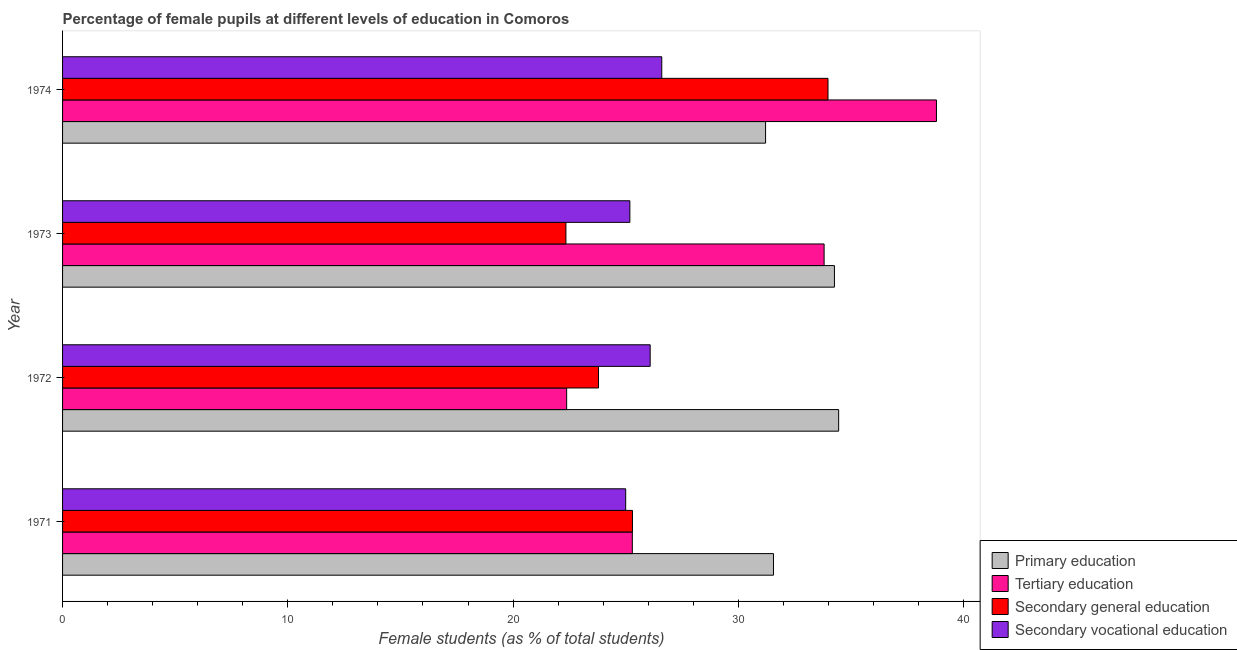How many different coloured bars are there?
Ensure brevity in your answer.  4. How many groups of bars are there?
Ensure brevity in your answer.  4. Are the number of bars per tick equal to the number of legend labels?
Offer a very short reply. Yes. How many bars are there on the 3rd tick from the top?
Keep it short and to the point. 4. What is the label of the 4th group of bars from the top?
Provide a short and direct response. 1971. In how many cases, is the number of bars for a given year not equal to the number of legend labels?
Your response must be concise. 0. What is the percentage of female students in tertiary education in 1973?
Provide a short and direct response. 33.81. Across all years, what is the maximum percentage of female students in secondary education?
Offer a very short reply. 33.98. Across all years, what is the minimum percentage of female students in secondary education?
Make the answer very short. 22.35. In which year was the percentage of female students in secondary vocational education maximum?
Offer a terse response. 1974. In which year was the percentage of female students in primary education minimum?
Your answer should be compact. 1974. What is the total percentage of female students in secondary vocational education in the graph?
Offer a very short reply. 102.87. What is the difference between the percentage of female students in secondary education in 1972 and that in 1973?
Make the answer very short. 1.45. What is the difference between the percentage of female students in secondary education in 1972 and the percentage of female students in tertiary education in 1974?
Provide a short and direct response. -15. What is the average percentage of female students in secondary education per year?
Make the answer very short. 26.36. In the year 1973, what is the difference between the percentage of female students in secondary vocational education and percentage of female students in primary education?
Offer a terse response. -9.08. What is the ratio of the percentage of female students in tertiary education in 1971 to that in 1974?
Offer a very short reply. 0.65. What is the difference between the highest and the second highest percentage of female students in primary education?
Provide a succinct answer. 0.19. What is the difference between the highest and the lowest percentage of female students in secondary education?
Give a very brief answer. 11.64. What does the 2nd bar from the top in 1973 represents?
Offer a terse response. Secondary general education. What does the 2nd bar from the bottom in 1974 represents?
Provide a succinct answer. Tertiary education. How many years are there in the graph?
Give a very brief answer. 4. What is the difference between two consecutive major ticks on the X-axis?
Make the answer very short. 10. Does the graph contain grids?
Your answer should be very brief. No. Where does the legend appear in the graph?
Your response must be concise. Bottom right. How many legend labels are there?
Your response must be concise. 4. How are the legend labels stacked?
Your answer should be compact. Vertical. What is the title of the graph?
Keep it short and to the point. Percentage of female pupils at different levels of education in Comoros. Does "Salary of employees" appear as one of the legend labels in the graph?
Your answer should be very brief. No. What is the label or title of the X-axis?
Give a very brief answer. Female students (as % of total students). What is the Female students (as % of total students) in Primary education in 1971?
Make the answer very short. 31.56. What is the Female students (as % of total students) in Tertiary education in 1971?
Your answer should be very brief. 25.29. What is the Female students (as % of total students) of Secondary general education in 1971?
Provide a succinct answer. 25.3. What is the Female students (as % of total students) of Primary education in 1972?
Provide a short and direct response. 34.45. What is the Female students (as % of total students) in Tertiary education in 1972?
Your response must be concise. 22.38. What is the Female students (as % of total students) in Secondary general education in 1972?
Provide a short and direct response. 23.79. What is the Female students (as % of total students) of Secondary vocational education in 1972?
Offer a very short reply. 26.09. What is the Female students (as % of total students) of Primary education in 1973?
Your response must be concise. 34.27. What is the Female students (as % of total students) in Tertiary education in 1973?
Make the answer very short. 33.81. What is the Female students (as % of total students) in Secondary general education in 1973?
Your response must be concise. 22.35. What is the Female students (as % of total students) in Secondary vocational education in 1973?
Offer a terse response. 25.19. What is the Female students (as % of total students) in Primary education in 1974?
Your response must be concise. 31.21. What is the Female students (as % of total students) in Tertiary education in 1974?
Offer a terse response. 38.8. What is the Female students (as % of total students) of Secondary general education in 1974?
Keep it short and to the point. 33.98. What is the Female students (as % of total students) of Secondary vocational education in 1974?
Offer a very short reply. 26.6. Across all years, what is the maximum Female students (as % of total students) of Primary education?
Make the answer very short. 34.45. Across all years, what is the maximum Female students (as % of total students) of Tertiary education?
Give a very brief answer. 38.8. Across all years, what is the maximum Female students (as % of total students) in Secondary general education?
Your answer should be compact. 33.98. Across all years, what is the maximum Female students (as % of total students) of Secondary vocational education?
Provide a succinct answer. 26.6. Across all years, what is the minimum Female students (as % of total students) of Primary education?
Offer a terse response. 31.21. Across all years, what is the minimum Female students (as % of total students) in Tertiary education?
Ensure brevity in your answer.  22.38. Across all years, what is the minimum Female students (as % of total students) in Secondary general education?
Provide a succinct answer. 22.35. What is the total Female students (as % of total students) of Primary education in the graph?
Provide a short and direct response. 131.49. What is the total Female students (as % of total students) of Tertiary education in the graph?
Ensure brevity in your answer.  120.28. What is the total Female students (as % of total students) of Secondary general education in the graph?
Provide a succinct answer. 105.42. What is the total Female students (as % of total students) of Secondary vocational education in the graph?
Your answer should be very brief. 102.87. What is the difference between the Female students (as % of total students) of Primary education in 1971 and that in 1972?
Your response must be concise. -2.89. What is the difference between the Female students (as % of total students) in Tertiary education in 1971 and that in 1972?
Your response must be concise. 2.92. What is the difference between the Female students (as % of total students) of Secondary general education in 1971 and that in 1972?
Ensure brevity in your answer.  1.51. What is the difference between the Female students (as % of total students) in Secondary vocational education in 1971 and that in 1972?
Make the answer very short. -1.09. What is the difference between the Female students (as % of total students) of Primary education in 1971 and that in 1973?
Make the answer very short. -2.71. What is the difference between the Female students (as % of total students) of Tertiary education in 1971 and that in 1973?
Your answer should be compact. -8.51. What is the difference between the Female students (as % of total students) in Secondary general education in 1971 and that in 1973?
Provide a succinct answer. 2.95. What is the difference between the Female students (as % of total students) in Secondary vocational education in 1971 and that in 1973?
Offer a terse response. -0.19. What is the difference between the Female students (as % of total students) of Primary education in 1971 and that in 1974?
Your response must be concise. 0.35. What is the difference between the Female students (as % of total students) of Tertiary education in 1971 and that in 1974?
Provide a short and direct response. -13.5. What is the difference between the Female students (as % of total students) in Secondary general education in 1971 and that in 1974?
Offer a very short reply. -8.68. What is the difference between the Female students (as % of total students) in Secondary vocational education in 1971 and that in 1974?
Offer a very short reply. -1.6. What is the difference between the Female students (as % of total students) of Primary education in 1972 and that in 1973?
Your answer should be very brief. 0.19. What is the difference between the Female students (as % of total students) in Tertiary education in 1972 and that in 1973?
Offer a terse response. -11.43. What is the difference between the Female students (as % of total students) in Secondary general education in 1972 and that in 1973?
Provide a succinct answer. 1.45. What is the difference between the Female students (as % of total students) of Secondary vocational education in 1972 and that in 1973?
Make the answer very short. 0.9. What is the difference between the Female students (as % of total students) of Primary education in 1972 and that in 1974?
Offer a very short reply. 3.24. What is the difference between the Female students (as % of total students) of Tertiary education in 1972 and that in 1974?
Make the answer very short. -16.42. What is the difference between the Female students (as % of total students) in Secondary general education in 1972 and that in 1974?
Your response must be concise. -10.19. What is the difference between the Female students (as % of total students) in Secondary vocational education in 1972 and that in 1974?
Keep it short and to the point. -0.52. What is the difference between the Female students (as % of total students) in Primary education in 1973 and that in 1974?
Ensure brevity in your answer.  3.06. What is the difference between the Female students (as % of total students) of Tertiary education in 1973 and that in 1974?
Offer a very short reply. -4.99. What is the difference between the Female students (as % of total students) of Secondary general education in 1973 and that in 1974?
Give a very brief answer. -11.64. What is the difference between the Female students (as % of total students) in Secondary vocational education in 1973 and that in 1974?
Give a very brief answer. -1.42. What is the difference between the Female students (as % of total students) in Primary education in 1971 and the Female students (as % of total students) in Tertiary education in 1972?
Ensure brevity in your answer.  9.18. What is the difference between the Female students (as % of total students) of Primary education in 1971 and the Female students (as % of total students) of Secondary general education in 1972?
Provide a short and direct response. 7.77. What is the difference between the Female students (as % of total students) of Primary education in 1971 and the Female students (as % of total students) of Secondary vocational education in 1972?
Keep it short and to the point. 5.47. What is the difference between the Female students (as % of total students) in Tertiary education in 1971 and the Female students (as % of total students) in Secondary general education in 1972?
Offer a terse response. 1.5. What is the difference between the Female students (as % of total students) of Tertiary education in 1971 and the Female students (as % of total students) of Secondary vocational education in 1972?
Offer a terse response. -0.79. What is the difference between the Female students (as % of total students) of Secondary general education in 1971 and the Female students (as % of total students) of Secondary vocational education in 1972?
Offer a terse response. -0.79. What is the difference between the Female students (as % of total students) of Primary education in 1971 and the Female students (as % of total students) of Tertiary education in 1973?
Your answer should be very brief. -2.25. What is the difference between the Female students (as % of total students) of Primary education in 1971 and the Female students (as % of total students) of Secondary general education in 1973?
Keep it short and to the point. 9.21. What is the difference between the Female students (as % of total students) in Primary education in 1971 and the Female students (as % of total students) in Secondary vocational education in 1973?
Offer a terse response. 6.38. What is the difference between the Female students (as % of total students) of Tertiary education in 1971 and the Female students (as % of total students) of Secondary general education in 1973?
Your answer should be compact. 2.95. What is the difference between the Female students (as % of total students) of Tertiary education in 1971 and the Female students (as % of total students) of Secondary vocational education in 1973?
Keep it short and to the point. 0.11. What is the difference between the Female students (as % of total students) of Secondary general education in 1971 and the Female students (as % of total students) of Secondary vocational education in 1973?
Provide a short and direct response. 0.12. What is the difference between the Female students (as % of total students) in Primary education in 1971 and the Female students (as % of total students) in Tertiary education in 1974?
Ensure brevity in your answer.  -7.24. What is the difference between the Female students (as % of total students) of Primary education in 1971 and the Female students (as % of total students) of Secondary general education in 1974?
Provide a succinct answer. -2.42. What is the difference between the Female students (as % of total students) of Primary education in 1971 and the Female students (as % of total students) of Secondary vocational education in 1974?
Give a very brief answer. 4.96. What is the difference between the Female students (as % of total students) of Tertiary education in 1971 and the Female students (as % of total students) of Secondary general education in 1974?
Your answer should be compact. -8.69. What is the difference between the Female students (as % of total students) in Tertiary education in 1971 and the Female students (as % of total students) in Secondary vocational education in 1974?
Your answer should be very brief. -1.31. What is the difference between the Female students (as % of total students) of Secondary general education in 1971 and the Female students (as % of total students) of Secondary vocational education in 1974?
Your answer should be compact. -1.3. What is the difference between the Female students (as % of total students) of Primary education in 1972 and the Female students (as % of total students) of Tertiary education in 1973?
Ensure brevity in your answer.  0.65. What is the difference between the Female students (as % of total students) of Primary education in 1972 and the Female students (as % of total students) of Secondary general education in 1973?
Offer a terse response. 12.11. What is the difference between the Female students (as % of total students) in Primary education in 1972 and the Female students (as % of total students) in Secondary vocational education in 1973?
Offer a terse response. 9.27. What is the difference between the Female students (as % of total students) in Tertiary education in 1972 and the Female students (as % of total students) in Secondary general education in 1973?
Your answer should be very brief. 0.03. What is the difference between the Female students (as % of total students) in Tertiary education in 1972 and the Female students (as % of total students) in Secondary vocational education in 1973?
Make the answer very short. -2.81. What is the difference between the Female students (as % of total students) in Secondary general education in 1972 and the Female students (as % of total students) in Secondary vocational education in 1973?
Offer a terse response. -1.39. What is the difference between the Female students (as % of total students) in Primary education in 1972 and the Female students (as % of total students) in Tertiary education in 1974?
Your answer should be compact. -4.34. What is the difference between the Female students (as % of total students) of Primary education in 1972 and the Female students (as % of total students) of Secondary general education in 1974?
Provide a short and direct response. 0.47. What is the difference between the Female students (as % of total students) in Primary education in 1972 and the Female students (as % of total students) in Secondary vocational education in 1974?
Give a very brief answer. 7.85. What is the difference between the Female students (as % of total students) of Tertiary education in 1972 and the Female students (as % of total students) of Secondary general education in 1974?
Provide a short and direct response. -11.6. What is the difference between the Female students (as % of total students) in Tertiary education in 1972 and the Female students (as % of total students) in Secondary vocational education in 1974?
Your answer should be very brief. -4.22. What is the difference between the Female students (as % of total students) in Secondary general education in 1972 and the Female students (as % of total students) in Secondary vocational education in 1974?
Keep it short and to the point. -2.81. What is the difference between the Female students (as % of total students) of Primary education in 1973 and the Female students (as % of total students) of Tertiary education in 1974?
Your answer should be very brief. -4.53. What is the difference between the Female students (as % of total students) in Primary education in 1973 and the Female students (as % of total students) in Secondary general education in 1974?
Make the answer very short. 0.29. What is the difference between the Female students (as % of total students) of Primary education in 1973 and the Female students (as % of total students) of Secondary vocational education in 1974?
Your answer should be very brief. 7.67. What is the difference between the Female students (as % of total students) of Tertiary education in 1973 and the Female students (as % of total students) of Secondary general education in 1974?
Offer a very short reply. -0.17. What is the difference between the Female students (as % of total students) in Tertiary education in 1973 and the Female students (as % of total students) in Secondary vocational education in 1974?
Ensure brevity in your answer.  7.21. What is the difference between the Female students (as % of total students) of Secondary general education in 1973 and the Female students (as % of total students) of Secondary vocational education in 1974?
Your response must be concise. -4.26. What is the average Female students (as % of total students) of Primary education per year?
Offer a terse response. 32.87. What is the average Female students (as % of total students) in Tertiary education per year?
Your answer should be compact. 30.07. What is the average Female students (as % of total students) in Secondary general education per year?
Make the answer very short. 26.36. What is the average Female students (as % of total students) in Secondary vocational education per year?
Provide a short and direct response. 25.72. In the year 1971, what is the difference between the Female students (as % of total students) of Primary education and Female students (as % of total students) of Tertiary education?
Offer a terse response. 6.27. In the year 1971, what is the difference between the Female students (as % of total students) in Primary education and Female students (as % of total students) in Secondary general education?
Your answer should be compact. 6.26. In the year 1971, what is the difference between the Female students (as % of total students) of Primary education and Female students (as % of total students) of Secondary vocational education?
Provide a short and direct response. 6.56. In the year 1971, what is the difference between the Female students (as % of total students) of Tertiary education and Female students (as % of total students) of Secondary general education?
Give a very brief answer. -0.01. In the year 1971, what is the difference between the Female students (as % of total students) in Tertiary education and Female students (as % of total students) in Secondary vocational education?
Make the answer very short. 0.29. In the year 1971, what is the difference between the Female students (as % of total students) in Secondary general education and Female students (as % of total students) in Secondary vocational education?
Your response must be concise. 0.3. In the year 1972, what is the difference between the Female students (as % of total students) in Primary education and Female students (as % of total students) in Tertiary education?
Provide a succinct answer. 12.08. In the year 1972, what is the difference between the Female students (as % of total students) in Primary education and Female students (as % of total students) in Secondary general education?
Keep it short and to the point. 10.66. In the year 1972, what is the difference between the Female students (as % of total students) of Primary education and Female students (as % of total students) of Secondary vocational education?
Offer a terse response. 8.37. In the year 1972, what is the difference between the Female students (as % of total students) in Tertiary education and Female students (as % of total students) in Secondary general education?
Keep it short and to the point. -1.41. In the year 1972, what is the difference between the Female students (as % of total students) in Tertiary education and Female students (as % of total students) in Secondary vocational education?
Offer a terse response. -3.71. In the year 1972, what is the difference between the Female students (as % of total students) of Secondary general education and Female students (as % of total students) of Secondary vocational education?
Your answer should be very brief. -2.29. In the year 1973, what is the difference between the Female students (as % of total students) of Primary education and Female students (as % of total students) of Tertiary education?
Provide a short and direct response. 0.46. In the year 1973, what is the difference between the Female students (as % of total students) in Primary education and Female students (as % of total students) in Secondary general education?
Your answer should be compact. 11.92. In the year 1973, what is the difference between the Female students (as % of total students) in Primary education and Female students (as % of total students) in Secondary vocational education?
Provide a succinct answer. 9.08. In the year 1973, what is the difference between the Female students (as % of total students) in Tertiary education and Female students (as % of total students) in Secondary general education?
Provide a succinct answer. 11.46. In the year 1973, what is the difference between the Female students (as % of total students) in Tertiary education and Female students (as % of total students) in Secondary vocational education?
Provide a succinct answer. 8.62. In the year 1973, what is the difference between the Female students (as % of total students) in Secondary general education and Female students (as % of total students) in Secondary vocational education?
Offer a very short reply. -2.84. In the year 1974, what is the difference between the Female students (as % of total students) of Primary education and Female students (as % of total students) of Tertiary education?
Offer a terse response. -7.59. In the year 1974, what is the difference between the Female students (as % of total students) in Primary education and Female students (as % of total students) in Secondary general education?
Your answer should be compact. -2.77. In the year 1974, what is the difference between the Female students (as % of total students) of Primary education and Female students (as % of total students) of Secondary vocational education?
Your answer should be compact. 4.61. In the year 1974, what is the difference between the Female students (as % of total students) of Tertiary education and Female students (as % of total students) of Secondary general education?
Offer a very short reply. 4.82. In the year 1974, what is the difference between the Female students (as % of total students) of Tertiary education and Female students (as % of total students) of Secondary vocational education?
Ensure brevity in your answer.  12.19. In the year 1974, what is the difference between the Female students (as % of total students) of Secondary general education and Female students (as % of total students) of Secondary vocational education?
Keep it short and to the point. 7.38. What is the ratio of the Female students (as % of total students) in Primary education in 1971 to that in 1972?
Your response must be concise. 0.92. What is the ratio of the Female students (as % of total students) of Tertiary education in 1971 to that in 1972?
Ensure brevity in your answer.  1.13. What is the ratio of the Female students (as % of total students) of Secondary general education in 1971 to that in 1972?
Your answer should be very brief. 1.06. What is the ratio of the Female students (as % of total students) in Secondary vocational education in 1971 to that in 1972?
Make the answer very short. 0.96. What is the ratio of the Female students (as % of total students) of Primary education in 1971 to that in 1973?
Your answer should be very brief. 0.92. What is the ratio of the Female students (as % of total students) in Tertiary education in 1971 to that in 1973?
Offer a terse response. 0.75. What is the ratio of the Female students (as % of total students) in Secondary general education in 1971 to that in 1973?
Keep it short and to the point. 1.13. What is the ratio of the Female students (as % of total students) of Primary education in 1971 to that in 1974?
Provide a succinct answer. 1.01. What is the ratio of the Female students (as % of total students) of Tertiary education in 1971 to that in 1974?
Provide a succinct answer. 0.65. What is the ratio of the Female students (as % of total students) of Secondary general education in 1971 to that in 1974?
Your response must be concise. 0.74. What is the ratio of the Female students (as % of total students) of Secondary vocational education in 1971 to that in 1974?
Your response must be concise. 0.94. What is the ratio of the Female students (as % of total students) of Tertiary education in 1972 to that in 1973?
Make the answer very short. 0.66. What is the ratio of the Female students (as % of total students) of Secondary general education in 1972 to that in 1973?
Provide a short and direct response. 1.06. What is the ratio of the Female students (as % of total students) of Secondary vocational education in 1972 to that in 1973?
Offer a terse response. 1.04. What is the ratio of the Female students (as % of total students) in Primary education in 1972 to that in 1974?
Make the answer very short. 1.1. What is the ratio of the Female students (as % of total students) in Tertiary education in 1972 to that in 1974?
Ensure brevity in your answer.  0.58. What is the ratio of the Female students (as % of total students) of Secondary general education in 1972 to that in 1974?
Provide a succinct answer. 0.7. What is the ratio of the Female students (as % of total students) in Secondary vocational education in 1972 to that in 1974?
Your response must be concise. 0.98. What is the ratio of the Female students (as % of total students) in Primary education in 1973 to that in 1974?
Offer a terse response. 1.1. What is the ratio of the Female students (as % of total students) of Tertiary education in 1973 to that in 1974?
Give a very brief answer. 0.87. What is the ratio of the Female students (as % of total students) in Secondary general education in 1973 to that in 1974?
Your answer should be very brief. 0.66. What is the ratio of the Female students (as % of total students) in Secondary vocational education in 1973 to that in 1974?
Make the answer very short. 0.95. What is the difference between the highest and the second highest Female students (as % of total students) in Primary education?
Provide a short and direct response. 0.19. What is the difference between the highest and the second highest Female students (as % of total students) of Tertiary education?
Your answer should be compact. 4.99. What is the difference between the highest and the second highest Female students (as % of total students) of Secondary general education?
Keep it short and to the point. 8.68. What is the difference between the highest and the second highest Female students (as % of total students) of Secondary vocational education?
Provide a succinct answer. 0.52. What is the difference between the highest and the lowest Female students (as % of total students) of Primary education?
Give a very brief answer. 3.24. What is the difference between the highest and the lowest Female students (as % of total students) of Tertiary education?
Your answer should be very brief. 16.42. What is the difference between the highest and the lowest Female students (as % of total students) of Secondary general education?
Make the answer very short. 11.64. What is the difference between the highest and the lowest Female students (as % of total students) in Secondary vocational education?
Keep it short and to the point. 1.6. 